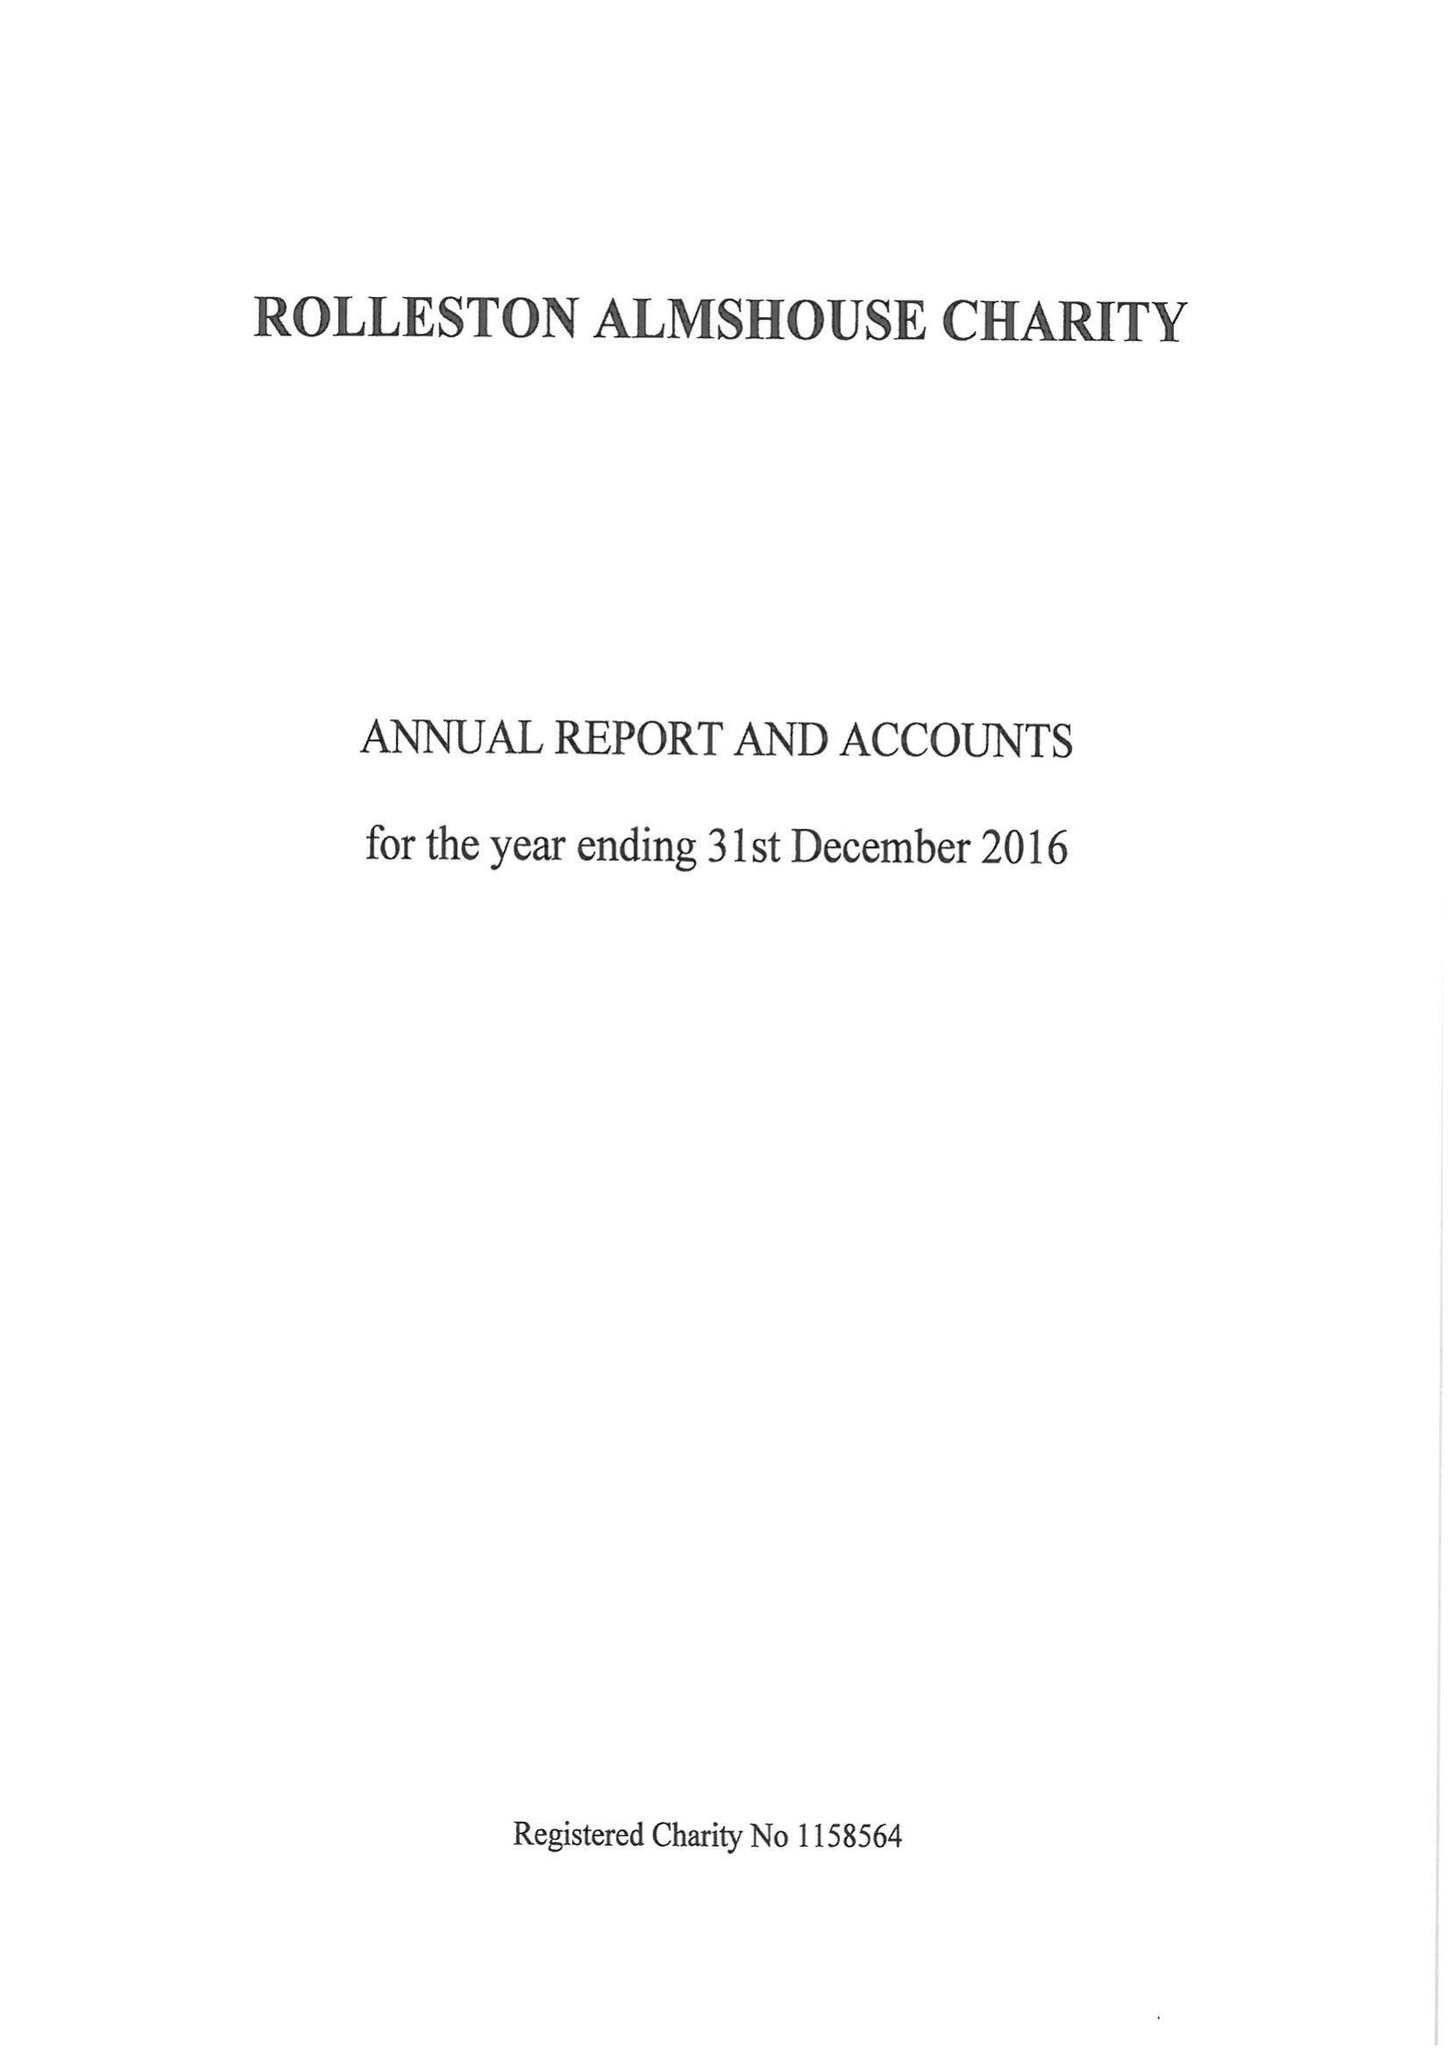What is the value for the charity_number?
Answer the question using a single word or phrase. 1158564 